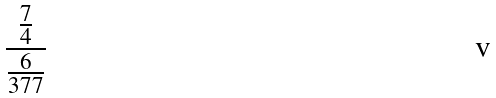Convert formula to latex. <formula><loc_0><loc_0><loc_500><loc_500>\frac { \frac { 7 } { 4 } } { \frac { 6 } { 3 7 7 } }</formula> 